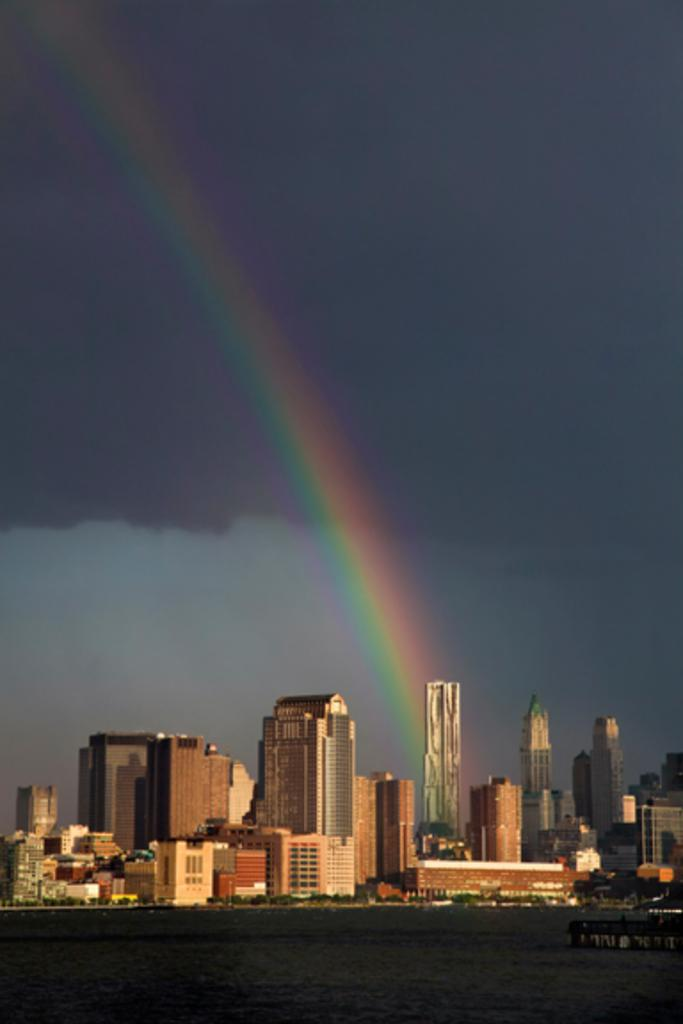What type of structures are present in the image? There are skyscrapers and buildings in the image. What is the main feature of the landscape in the image? There is a road in the image. What is located on the water in the image? There is a boat on the water in the image. What natural phenomenon can be seen in the image? There is a rainbow in the image. What part of the environment is visible in the image? The sky is visible in the image. What else can be seen in the sky in the image? There are clouds in the image. What is the health status of the head of the boat in the image? There is no indication of the health status of the head of the boat in the image, as boats do not have heads. 